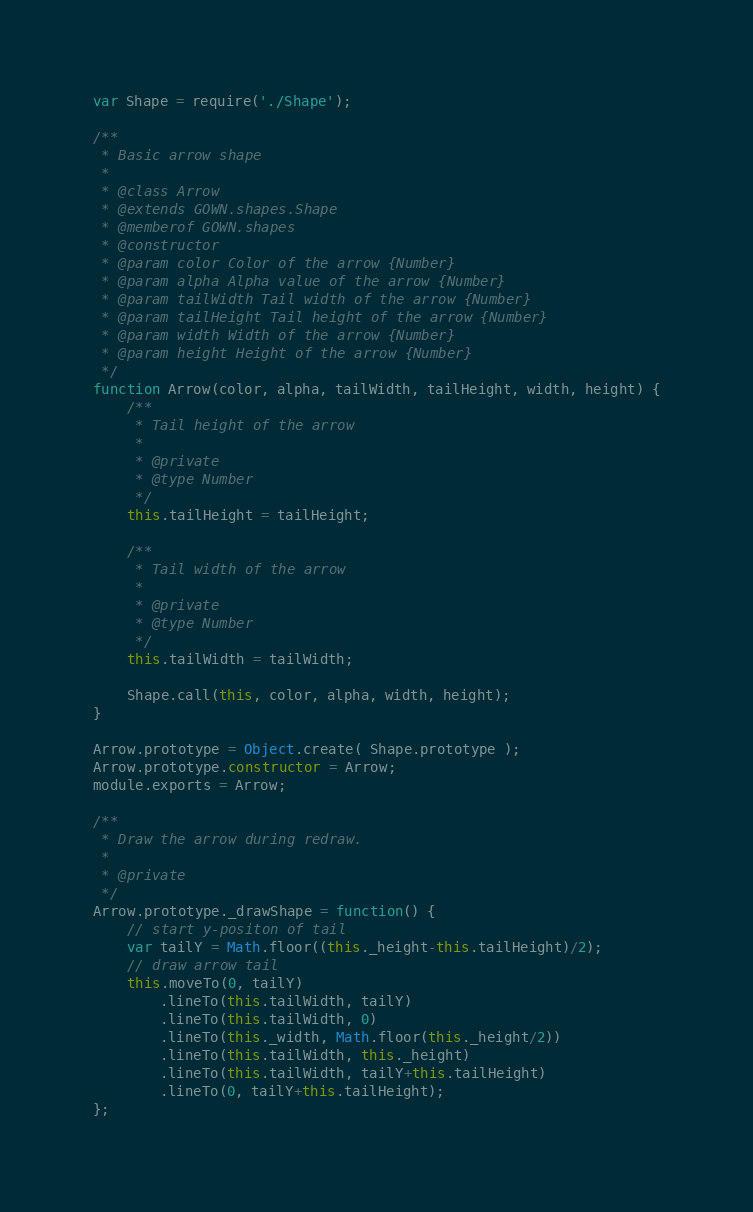<code> <loc_0><loc_0><loc_500><loc_500><_JavaScript_>var Shape = require('./Shape');

/**
 * Basic arrow shape
 *
 * @class Arrow
 * @extends GOWN.shapes.Shape
 * @memberof GOWN.shapes
 * @constructor
 * @param color Color of the arrow {Number}
 * @param alpha Alpha value of the arrow {Number}
 * @param tailWidth Tail width of the arrow {Number}
 * @param tailHeight Tail height of the arrow {Number}
 * @param width Width of the arrow {Number}
 * @param height Height of the arrow {Number}
 */
function Arrow(color, alpha, tailWidth, tailHeight, width, height) {
    /**
     * Tail height of the arrow
     *
     * @private
     * @type Number
     */
    this.tailHeight = tailHeight;

    /**
     * Tail width of the arrow
     *
     * @private
     * @type Number
     */
    this.tailWidth = tailWidth;

    Shape.call(this, color, alpha, width, height);
}

Arrow.prototype = Object.create( Shape.prototype );
Arrow.prototype.constructor = Arrow;
module.exports = Arrow;

/**
 * Draw the arrow during redraw.
 *
 * @private
 */
Arrow.prototype._drawShape = function() {
    // start y-positon of tail
    var tailY = Math.floor((this._height-this.tailHeight)/2);
    // draw arrow tail
    this.moveTo(0, tailY)
        .lineTo(this.tailWidth, tailY)
        .lineTo(this.tailWidth, 0)
        .lineTo(this._width, Math.floor(this._height/2))
        .lineTo(this.tailWidth, this._height)
        .lineTo(this.tailWidth, tailY+this.tailHeight)
        .lineTo(0, tailY+this.tailHeight);
};
</code> 